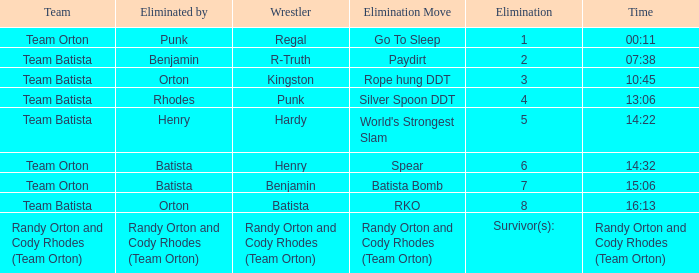Which Elimination move is listed against Team Orton, Eliminated by Batista against Elimination number 7? Batista Bomb. 